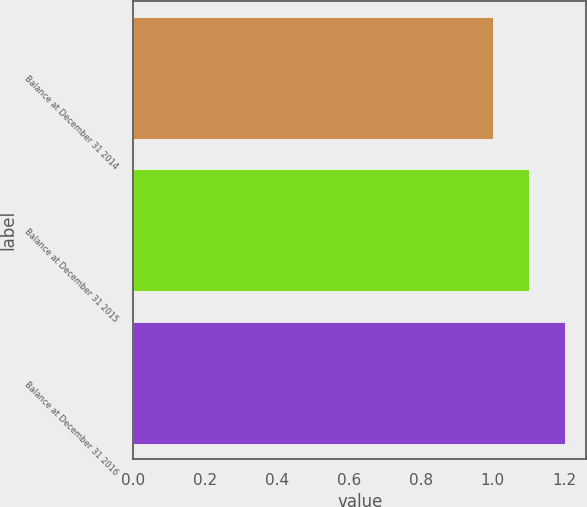Convert chart to OTSL. <chart><loc_0><loc_0><loc_500><loc_500><bar_chart><fcel>Balance at December 31 2014<fcel>Balance at December 31 2015<fcel>Balance at December 31 2016<nl><fcel>1<fcel>1.1<fcel>1.2<nl></chart> 